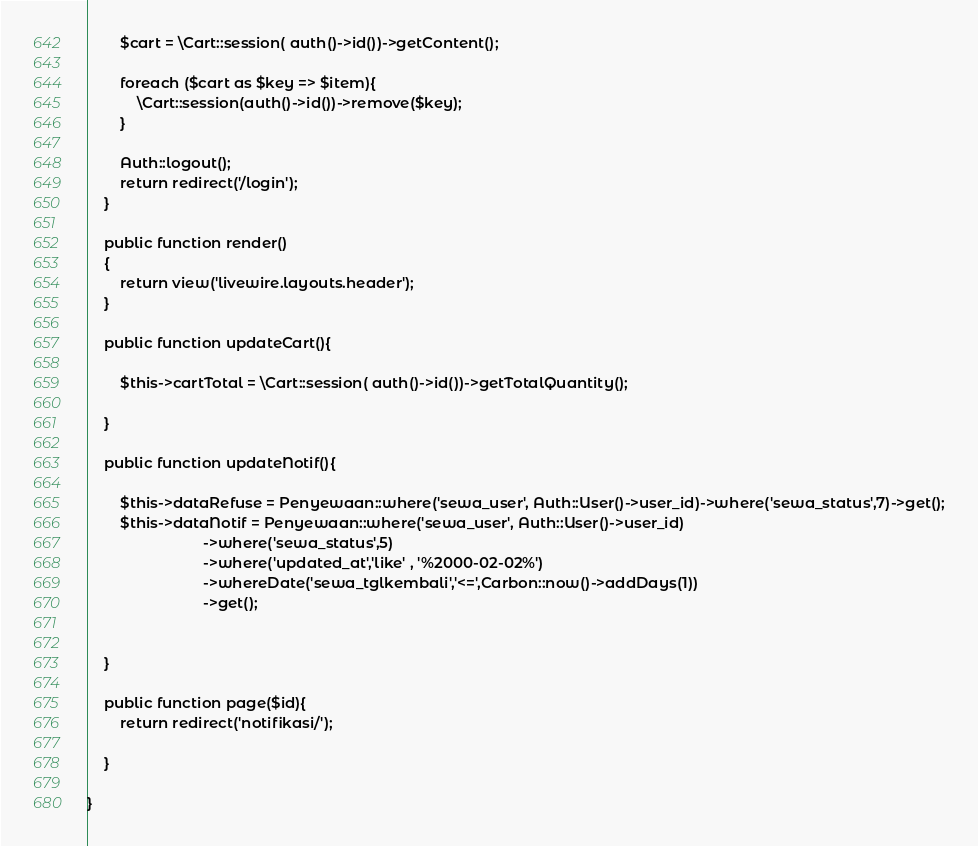Convert code to text. <code><loc_0><loc_0><loc_500><loc_500><_PHP_>        $cart = \Cart::session( auth()->id())->getContent();

        foreach ($cart as $key => $item){
            \Cart::session(auth()->id())->remove($key);
        }

        Auth::logout();
        return redirect('/login');
    }

    public function render()
    {
        return view('livewire.layouts.header');
    }

    public function updateCart(){

        $this->cartTotal = \Cart::session( auth()->id())->getTotalQuantity();

    }

    public function updateNotif(){

        $this->dataRefuse = Penyewaan::where('sewa_user', Auth::User()->user_id)->where('sewa_status',7)->get();
        $this->dataNotif = Penyewaan::where('sewa_user', Auth::User()->user_id)
                            ->where('sewa_status',5)
                            ->where('updated_at','like' , '%2000-02-02%')
                            ->whereDate('sewa_tglkembali','<=',Carbon::now()->addDays(1))
                            ->get();


    }

    public function page($id){
        return redirect('notifikasi/');

    }

}
</code> 